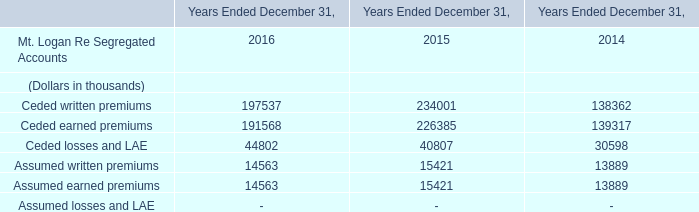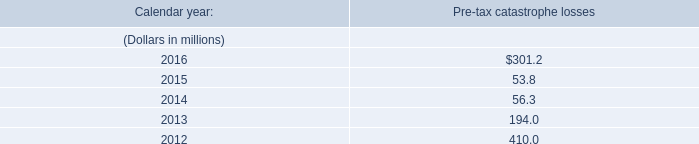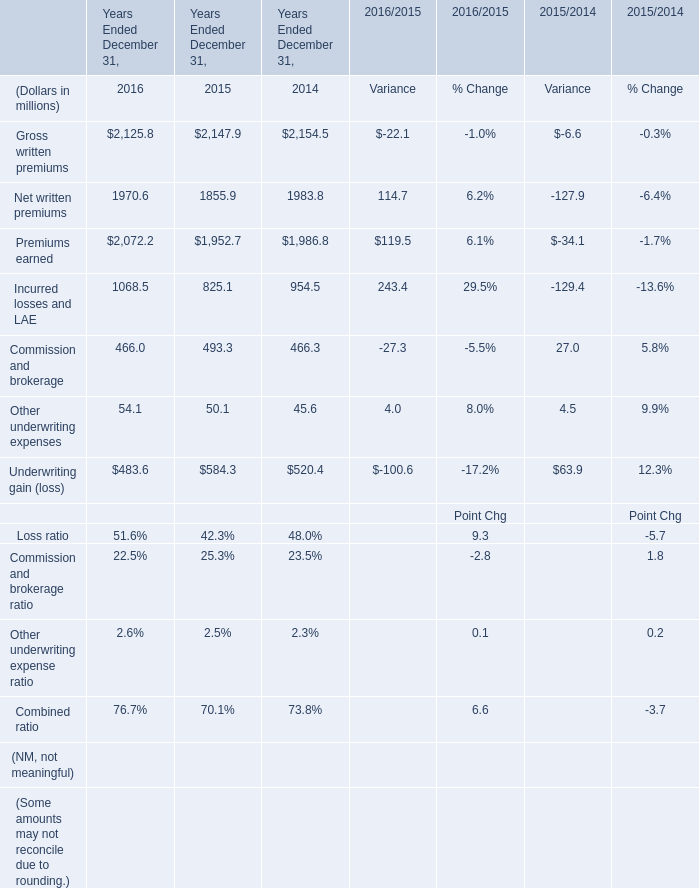What will premiums earned be like in 2017 if it develops with the same increasing rate as current? (in million) 
Computations: ((((2072.2 - 1952.7) / 1952.7) + 1) * 2072.2)
Answer: 2199.01308. 